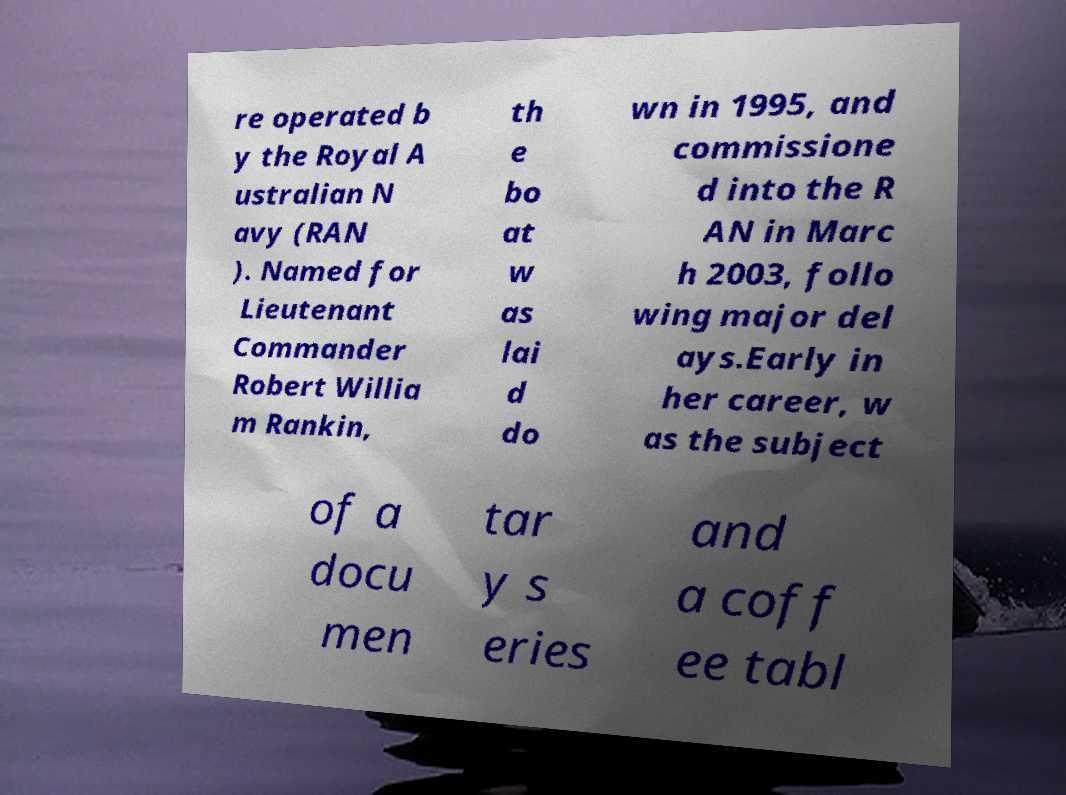Could you extract and type out the text from this image? re operated b y the Royal A ustralian N avy (RAN ). Named for Lieutenant Commander Robert Willia m Rankin, th e bo at w as lai d do wn in 1995, and commissione d into the R AN in Marc h 2003, follo wing major del ays.Early in her career, w as the subject of a docu men tar y s eries and a coff ee tabl 